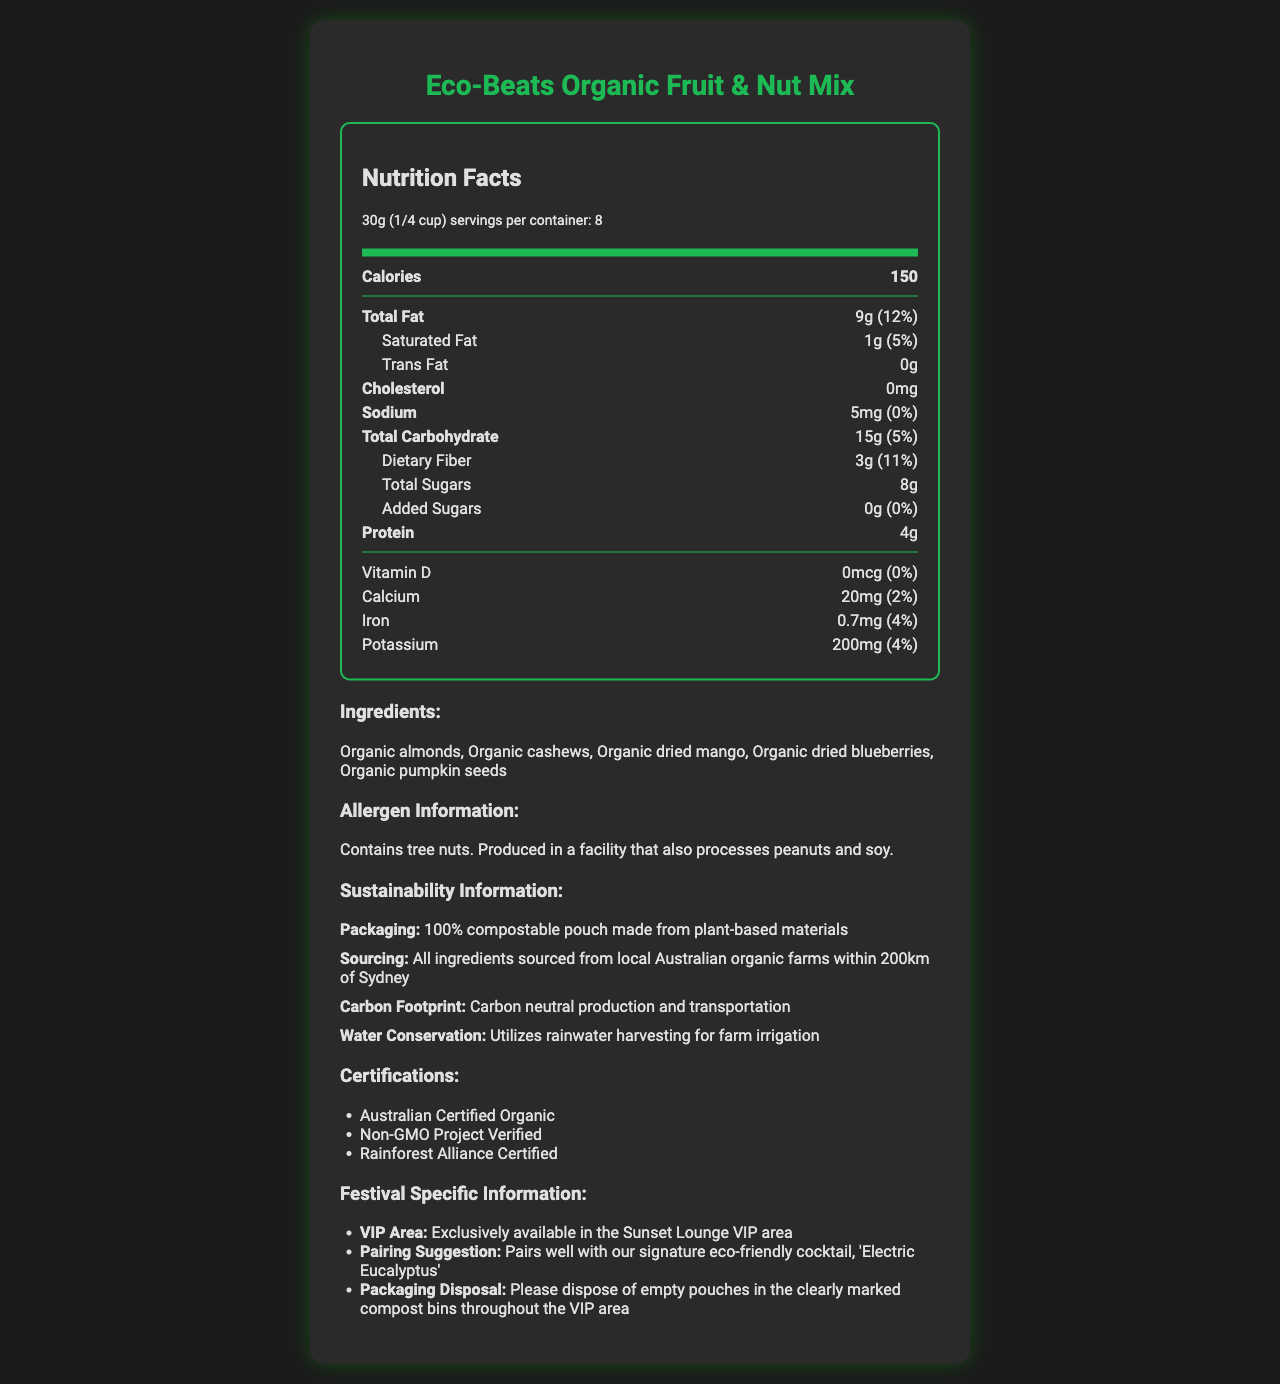what is the serving size? The serving size is explicitly stated as "30g (1/4 cup)" in the serving information section.
Answer: 30g (1/4 cup) how many calories are there per serving? The number of calories per serving is directly listed as 150 in the nutrition items section.
Answer: 150 where are the ingredients sourced from? Under the sustainability information section, it states that all ingredients are sourced from local Australian organic farms within 200km of Sydney.
Answer: Local Australian organic farms within 200km of Sydney what certifications does the product have? The certifications section lists the following: Australian Certified Organic, Non-GMO Project Verified, Rainforest Alliance Certified.
Answer: Australian Certified Organic, Non-GMO Project Verified, Rainforest Alliance Certified is there any cholesterol in the product? The nutrition section indicates that the product has 0mg of cholesterol.
Answer: No where should the empty pouches be disposed of at the festival? Under festival-specific information, it mentions that empty pouches should be disposed of in the clearly marked compost bins throughout the VIP area.
Answer: In the clearly marked compost bins throughout the VIP area what is the amount of protein per serving? The nutrition items section lists the amount of protein per serving as 4g.
Answer: 4g how many different types of certifications are listed? The certifications section lists three different certifications: Australian Certified Organic, Non-GMO Project Verified, Rainforest Alliance Certified.
Answer: 3 what type of fats are included and in what amounts? The nutrition items section lists: Total Fat 9g, Saturated Fat 1g, and Trans Fat 0g.
Answer: Total Fat 9g, Saturated Fat 1g, Trans Fat 0g what are the suggested pairings for the snack? The festival-specific information section mentions that the snack pairs well with the signature eco-friendly cocktail, 'Electric Eucalyptus'.
Answer: Signature eco-friendly cocktail, 'Electric Eucalyptus' in which VIP area is the snack available? Under festival-specific information, it is stated that the snack is exclusively available in the Sunset Lounge VIP area.
Answer: Sunset Lounge VIP area what is the packaging material of the product? The sustainability information section lists the packaging as 100% compostable pouch made from plant-based materials.
Answer: 100% compostable pouch made from plant-based materials does the product contain any added sugars? The nutrition items section states that the amount of added sugars is 0g.
Answer: No which ingredient is not included in the product? A. Organic almonds B. Organic cashews C. Organic chocolate D. Organic dried mango The ingredients list includes Organic almonds, Organic cashews, Organic dried mango, Organic dried blueberries, and Organic pumpkin seeds but does not mention Organic chocolate.
Answer: C. Organic chocolate what daily value percentage of dietary fiber does the product provide? The nutrition items section lists the daily value percentage of dietary fiber as 11%.
Answer: 11% is the product carbon neutral? The sustainability information section mentions that the product has a carbon-neutral production and transportation process.
Answer: Yes which nutrient has the highest daily value percentage? A. Total Fat B. Calcium C. Iron D. Potassium Among all the nutrients listed, Total Fat has the highest daily value percentage at 12%.
Answer: A. Total Fat which two essential nutrients are listed with no daily value percentage? Both Vitamin D (0%) and Sodium (0%) are listed with no effective daily value percentage.
Answer: Vitamin D and Sodium to whom might this document be of most interest? The festival-specific information suggests that the document is intended for attendees of the Sunset Lounge VIP area.
Answer: Attendees of the Sunset Lounge VIP area at the music festival what is the environmental benefit mentioned related to water conservation? The sustainability information section states that water conservation is achieved by utilizing rainwater harvesting for farm irrigation.
Answer: Utilizes rainwater harvesting for farm irrigation what is the main idea of the document? The document thoroughly details various aspects of the product, focusing on its organic and sustainable nature, suitable for festival VIP attendees.
Answer: The document provides detailed information about the Eco-Beats Organic Fruit & Nut Mix, including nutritional facts, ingredients, allergen information, sustainability practices, certifications, and festival-specific details for exclusive VIP area offerings. what is the total weight of the package? Although serving size and the number of servings per container are provided, the total weight is not directly mentioned in the document. Calculated as 30g per serving x 8 servings per container, the total weight would be 240g.
Answer: 240g 